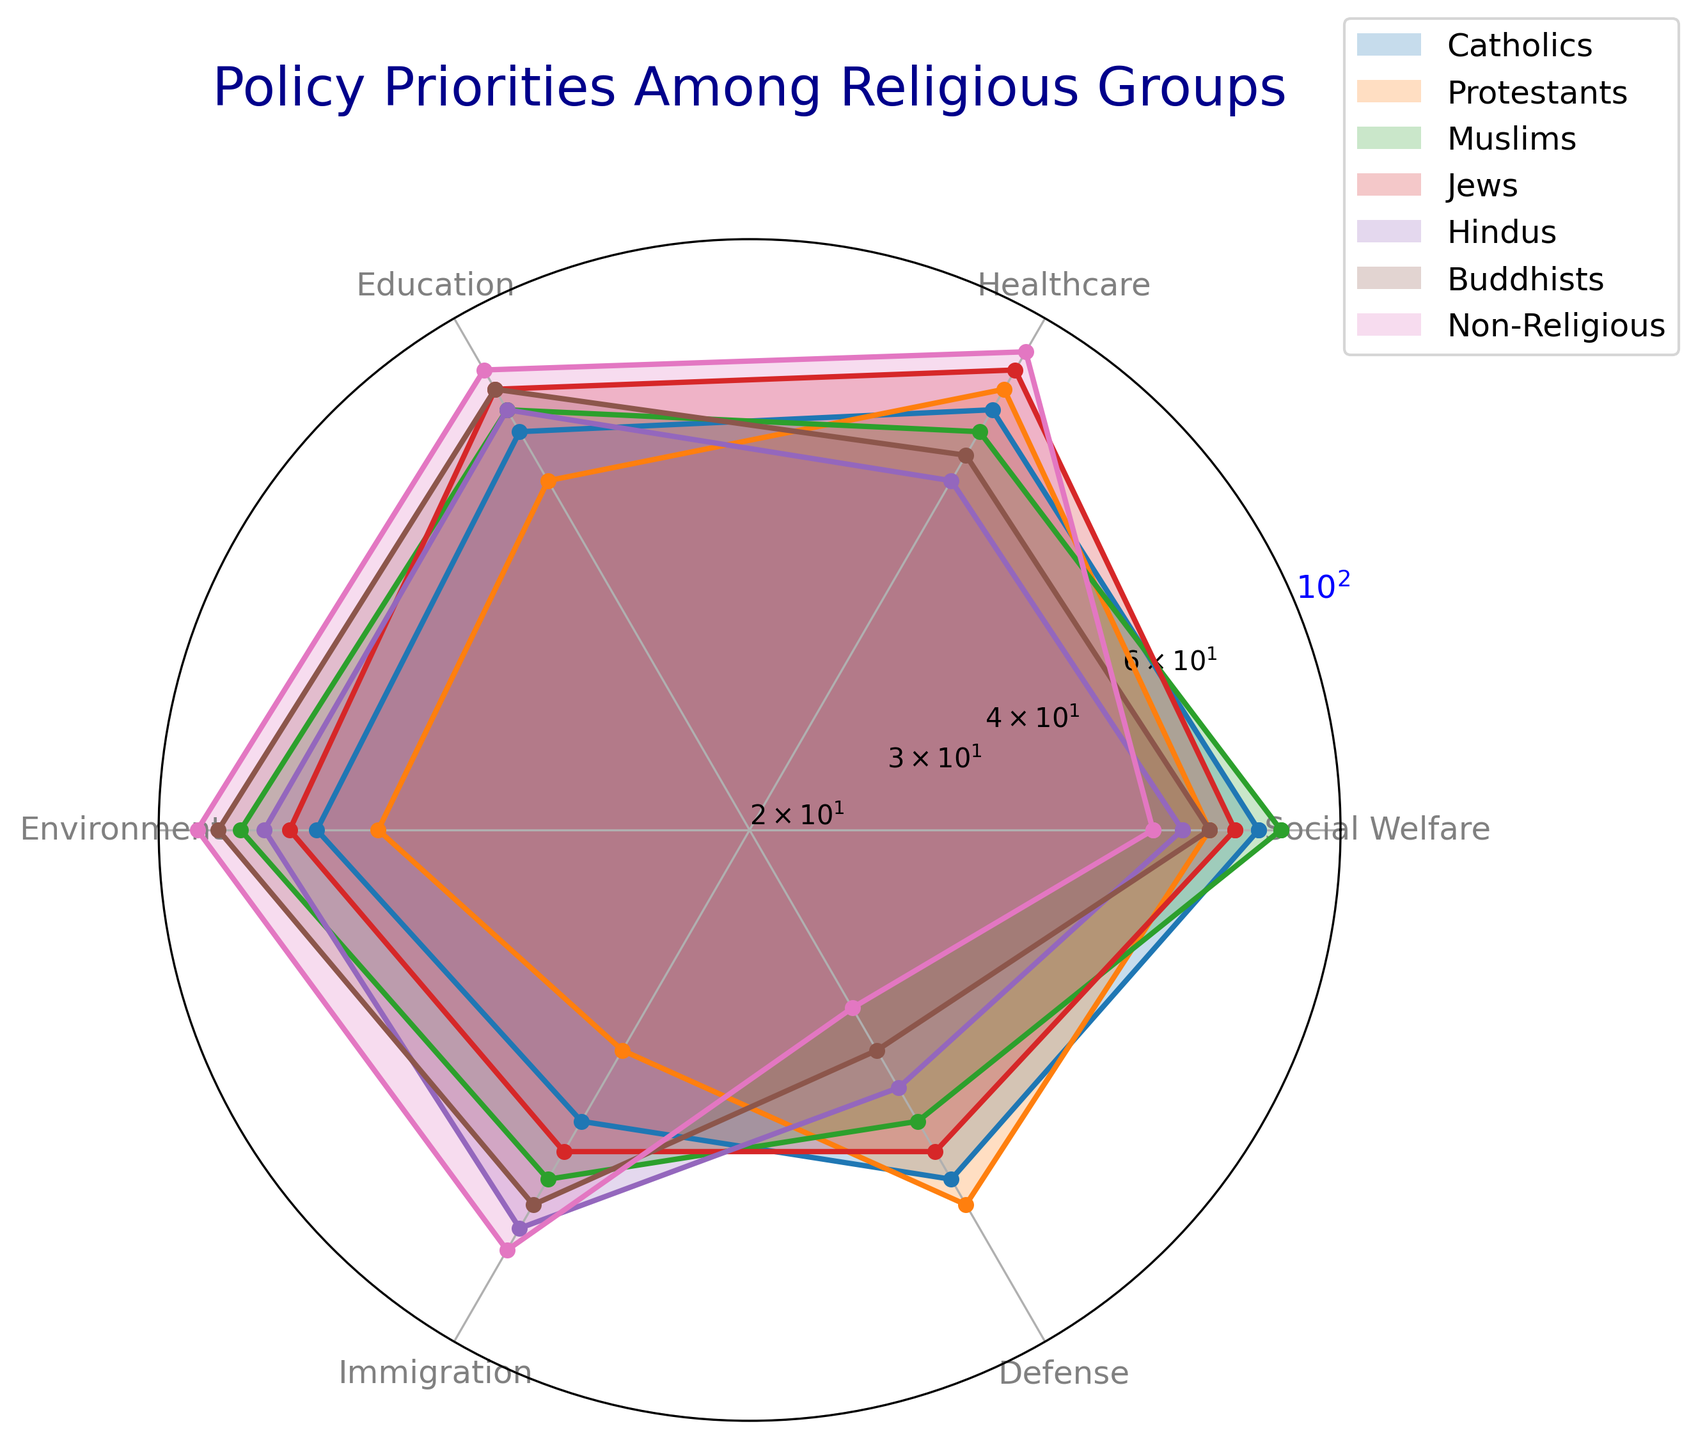Which religious group prioritizes Healthcare the most? By visually inspecting the radar chart, we observe that the Non-Religious group has the highest value (90) for Healthcare, indicated by the extent of the radar chart segment related to Healthcare.
Answer: Non-Religious Which two policy priorities do Buddhists seem to rank equally high? Observing the radar chart, the two policy areas where Buddhists have the highest points are Education and Environment, both at 80 and 85 respectively. The visual heights of these segments are comparable and noticeably higher compared to other priorities for Buddhists.
Answer: Education and Environment Which religious group has the lowest priority for Defense? By examining the segments for Defense, you'll notice that the Non-Religious group stands out with the smallest visual length, indicating the lowest value (35).
Answer: Non-Religious Compare the prioritization of Immigration between Catholics and Hindus. Who values it more and by how much? Catholics prioritize Immigration at a value of 50, while Hindus prioritize it at a value of 70. The difference between the two groups is calculated by 70 (Hindus) - 50 (Catholics) = 20.
Answer: Hindus, by 20 Among Muslims, Jews, and Buddhists, which group places the highest priority on Environment? From the radar chart, Muslims (80), Jews (70), and Buddhists (85) show different values for Environment. The Buddhists have the highest visual segment for Environment, indicating the highest priority.
Answer: Buddhists What is the average priority score for Education across all religious groups? Adding the Education values for all groups: 70 (Catholics) + 60 (Protestants) + 75 (Muslims) + 80 (Jews) + 75 (Hindus) + 80 (Buddhists) + 85 (Non-Religious) = 525. There are 7 groups, so the average is 525 / 7 = 75.
Answer: 75 How do Protestants' priorities for Defense compare to Muslims' priorities for the same policy? Visually inspect the radar chart for Defense: Protestants have a value of 65 and Muslims have a value of 50. The Protestant group's segment extends further, indicating they prioritize Defense more than Muslims by 15 (65 - 50 = 15).
Answer: Protestants, by 15 Which religious group has the most varied (highest range) priorities across the different policies? To find the range, subtract the minimum value from the maximum value for each group:  
- Catholics: 80-50 = 30  
- Protestants: 80-40 = 40  
- Muslims: 85-50 = 35  
- Jews: 85-55 = 30  
- Hindus: 75-45 = 30  
- Buddhists: 85-40 = 45  
- Non-Religious: 90-35 = 55  
The Non-Religious group's range of 55 is the highest among all groups.
Answer: Non-Religious What is the combined priority score for Social Welfare and Immigration among Jews? Jews prioritize Social Welfare at 75 and Immigration at 55. Combined score is 75 + 55 = 130.
Answer: 130 